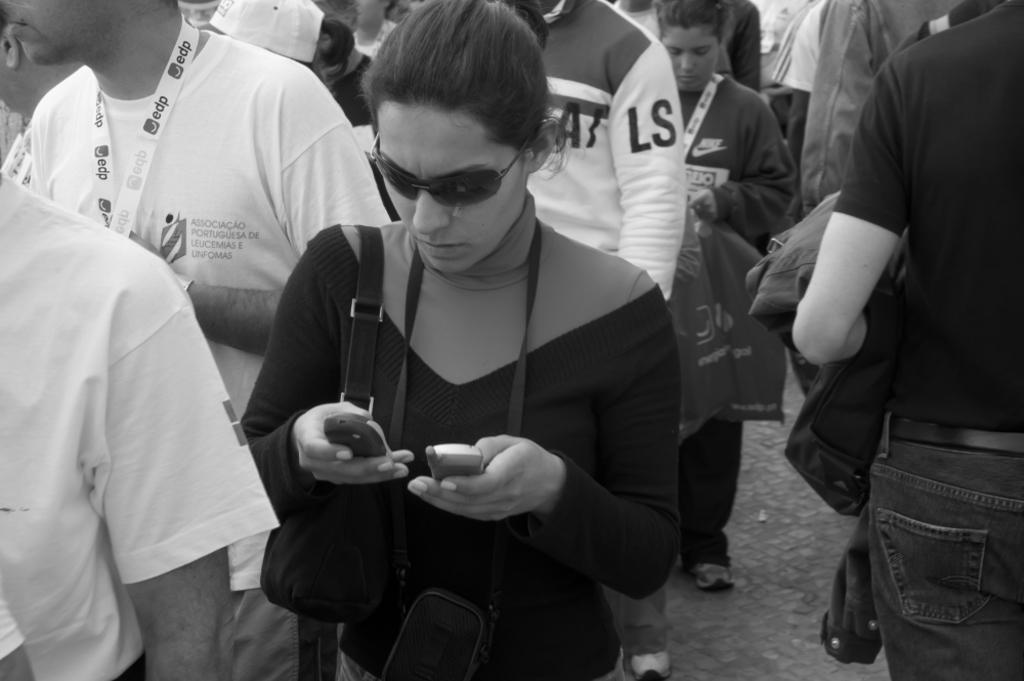What is the color scheme of the image? The image is black and white. Can you describe the subjects in the image? There are people in the image, including a woman in the foreground. What is the woman in the foreground doing? The woman is operating mobile phones. How many pizzas can be seen in the image? There are no pizzas present in the image. What type of shame is being expressed by the people in the image? There is no indication of shame or any emotion in the image; it only shows people and a woman operating mobile phones. 